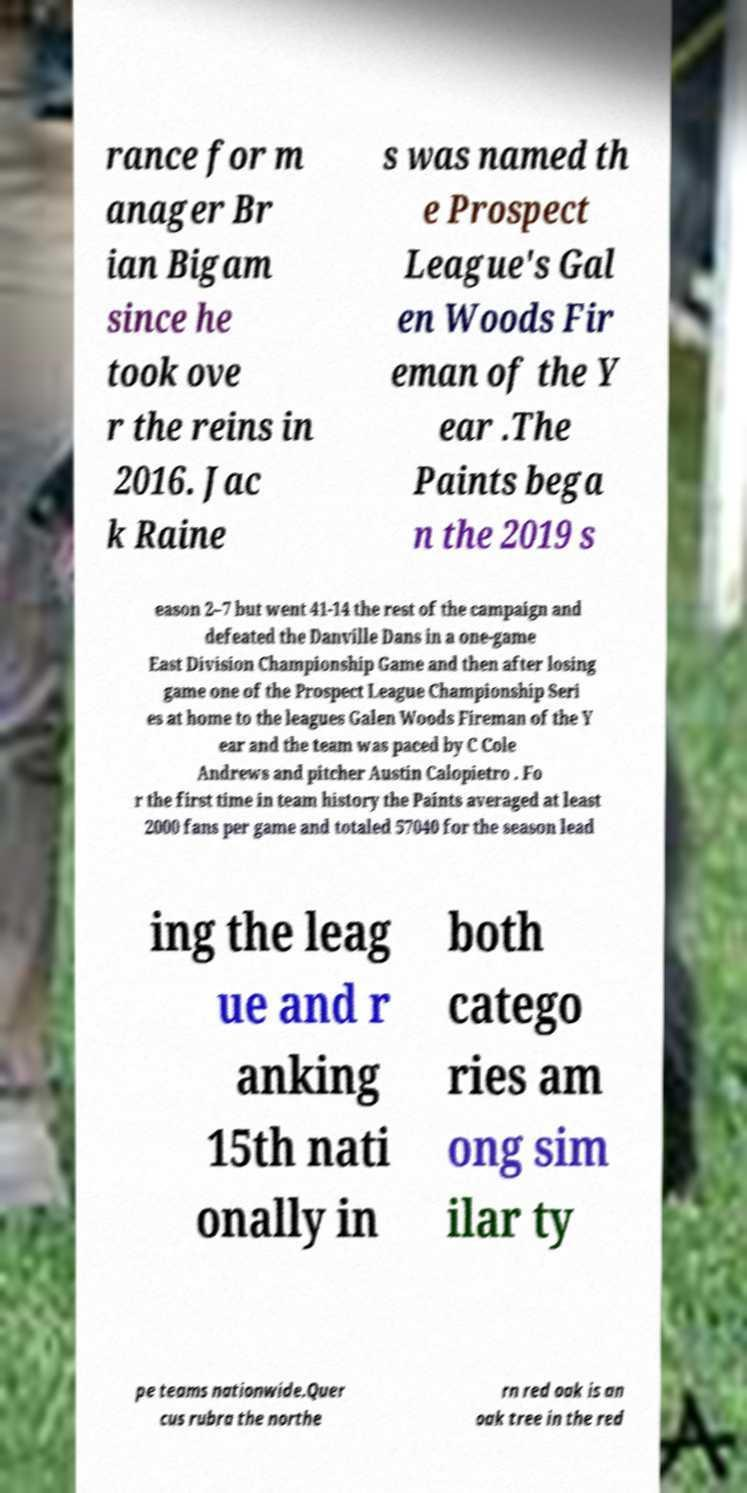I need the written content from this picture converted into text. Can you do that? rance for m anager Br ian Bigam since he took ove r the reins in 2016. Jac k Raine s was named th e Prospect League's Gal en Woods Fir eman of the Y ear .The Paints bega n the 2019 s eason 2–7 but went 41-14 the rest of the campaign and defeated the Danville Dans in a one-game East Division Championship Game and then after losing game one of the Prospect League Championship Seri es at home to the leagues Galen Woods Fireman of the Y ear and the team was paced by C Cole Andrews and pitcher Austin Calopietro . Fo r the first time in team history the Paints averaged at least 2000 fans per game and totaled 57040 for the season lead ing the leag ue and r anking 15th nati onally in both catego ries am ong sim ilar ty pe teams nationwide.Quer cus rubra the northe rn red oak is an oak tree in the red 